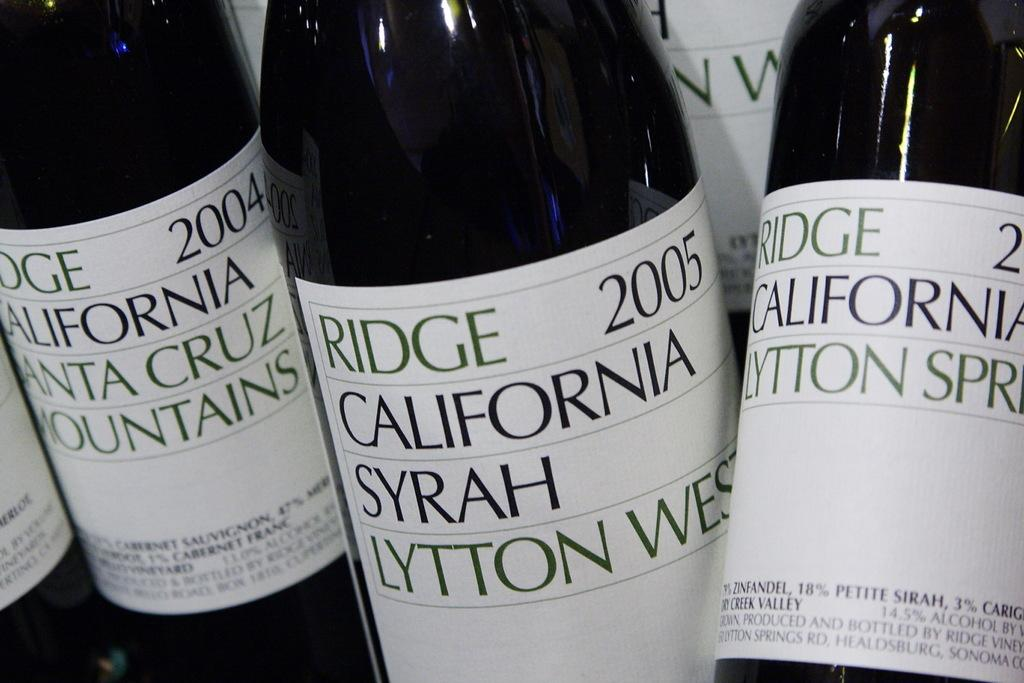<image>
Summarize the visual content of the image. Several bottles of Ridge  California Syrah wine. 